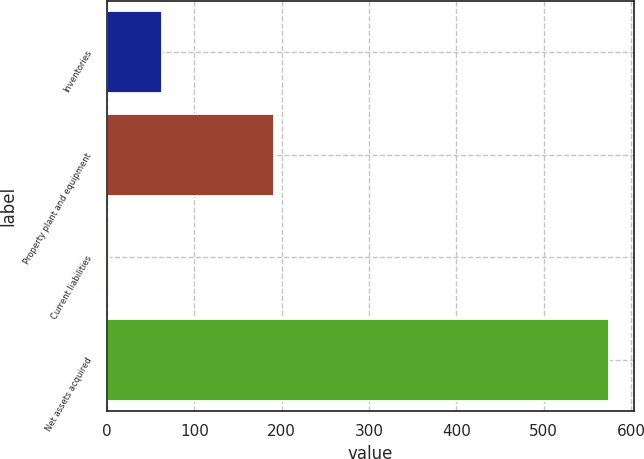<chart> <loc_0><loc_0><loc_500><loc_500><bar_chart><fcel>Inventories<fcel>Property plant and equipment<fcel>Current liabilities<fcel>Net assets acquired<nl><fcel>63.3<fcel>191.5<fcel>1.9<fcel>574.7<nl></chart> 